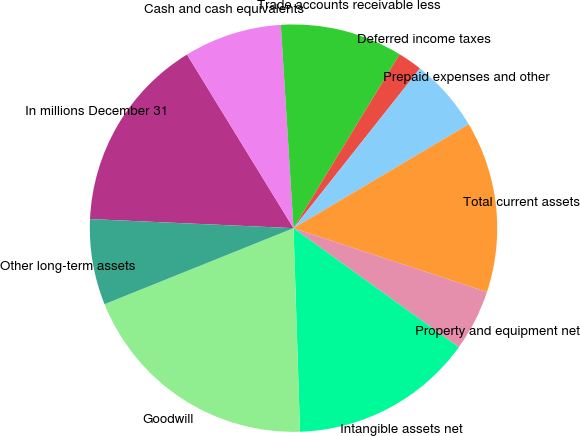Convert chart to OTSL. <chart><loc_0><loc_0><loc_500><loc_500><pie_chart><fcel>In millions December 31<fcel>Cash and cash equivalents<fcel>Trade accounts receivable less<fcel>Deferred income taxes<fcel>Prepaid expenses and other<fcel>Total current assets<fcel>Property and equipment net<fcel>Intangible assets net<fcel>Goodwill<fcel>Other long-term assets<nl><fcel>15.53%<fcel>7.77%<fcel>9.71%<fcel>1.94%<fcel>5.83%<fcel>13.59%<fcel>4.86%<fcel>14.56%<fcel>19.42%<fcel>6.8%<nl></chart> 